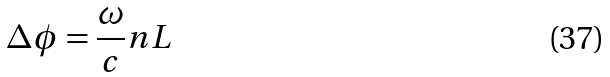Convert formula to latex. <formula><loc_0><loc_0><loc_500><loc_500>\Delta \phi = \frac { \omega } { c } n L</formula> 